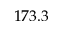Convert formula to latex. <formula><loc_0><loc_0><loc_500><loc_500>1 7 3 . 3</formula> 